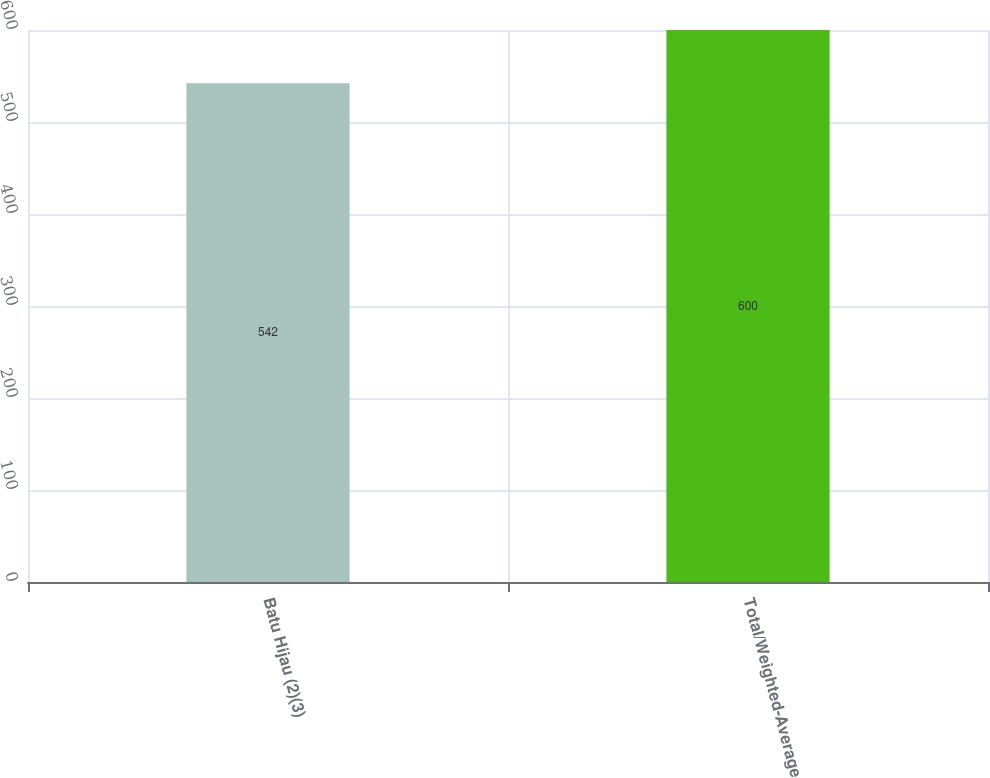<chart> <loc_0><loc_0><loc_500><loc_500><bar_chart><fcel>Batu Hijau (2)(3)<fcel>Total/Weighted-Average<nl><fcel>542<fcel>600<nl></chart> 